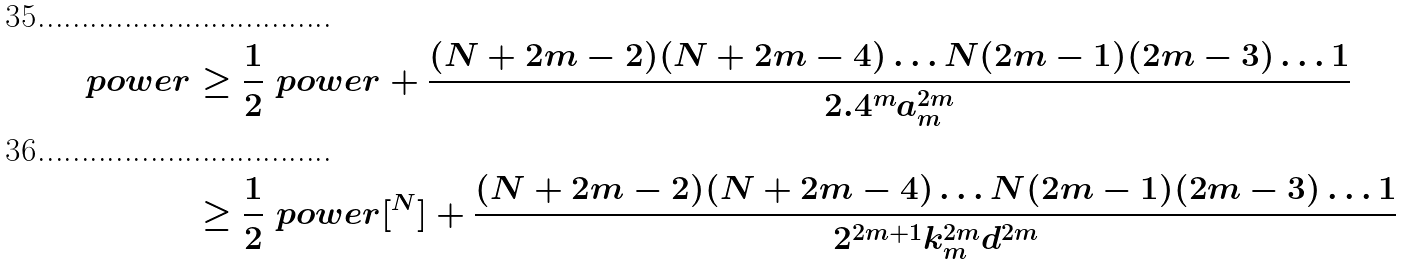<formula> <loc_0><loc_0><loc_500><loc_500>\ p o w e r & \geq \frac { 1 } { 2 } \ p o w e r + \frac { ( N + 2 m - 2 ) ( N + 2 m - 4 ) \dots N ( 2 m - 1 ) ( 2 m - 3 ) \dots 1 } { 2 . 4 ^ { m } a _ { m } ^ { 2 m } } \\ & \geq \frac { 1 } { 2 } \ p o w e r [ \real ^ { N } ] + \frac { ( N + 2 m - 2 ) ( N + 2 m - 4 ) \dots N ( 2 m - 1 ) ( 2 m - 3 ) \dots 1 } { 2 ^ { 2 m + 1 } k _ { m } ^ { 2 m } d ^ { 2 m } }</formula> 